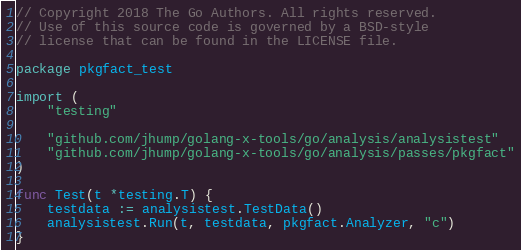<code> <loc_0><loc_0><loc_500><loc_500><_Go_>// Copyright 2018 The Go Authors. All rights reserved.
// Use of this source code is governed by a BSD-style
// license that can be found in the LICENSE file.

package pkgfact_test

import (
	"testing"

	"github.com/jhump/golang-x-tools/go/analysis/analysistest"
	"github.com/jhump/golang-x-tools/go/analysis/passes/pkgfact"
)

func Test(t *testing.T) {
	testdata := analysistest.TestData()
	analysistest.Run(t, testdata, pkgfact.Analyzer, "c")
}
</code> 